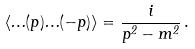Convert formula to latex. <formula><loc_0><loc_0><loc_500><loc_500>\langle \Phi ( p ) \Phi ( - p ) \rangle = \frac { i } { p ^ { 2 } - m ^ { 2 } } \, .</formula> 